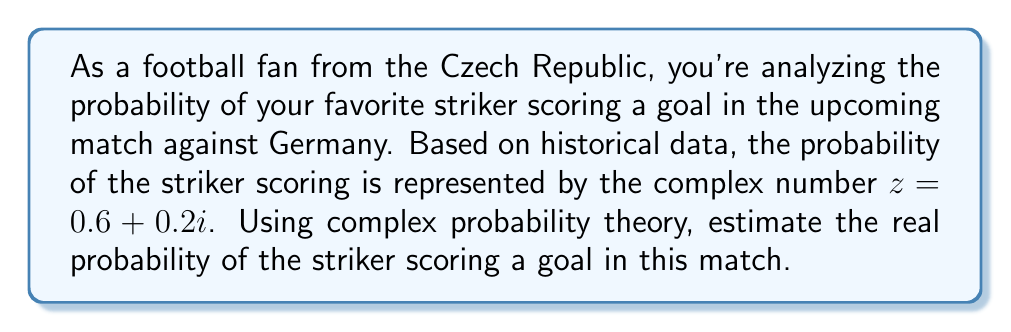Teach me how to tackle this problem. To solve this problem, we need to use complex probability theory. In this framework, the probability is represented by a complex number $z = a + bi$, where $a$ is the real part and $b$ is the imaginary part.

The real probability is estimated by calculating the squared magnitude of the complex number. This is done using the following steps:

1) The complex number given is $z = 0.6 + 0.2i$

2) To find the squared magnitude, we multiply $z$ by its complex conjugate $z^*$:

   $|z|^2 = z \cdot z^* = (0.6 + 0.2i)(0.6 - 0.2i)$

3) Expand this multiplication:

   $|z|^2 = (0.6)^2 + (0.2)^2 = 0.36 + 0.04$

4) Sum the results:

   $|z|^2 = 0.40$

5) The square root of this value gives us the magnitude of the complex number, which is our estimated real probability:

   $|z| = \sqrt{0.40} \approx 0.6325$

Therefore, the estimated real probability of the striker scoring a goal is approximately 0.6325 or 63.25%.
Answer: The estimated real probability of the striker scoring a goal is approximately 0.6325 or 63.25%. 